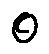<formula> <loc_0><loc_0><loc_500><loc_500>o</formula> 